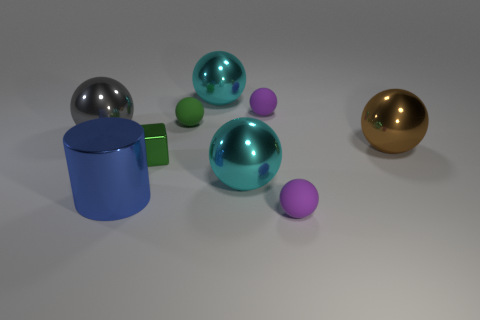What is the shape of the rubber thing that is the same color as the small metal object?
Keep it short and to the point. Sphere. There is a ball that is the same color as the tiny metal block; what size is it?
Provide a short and direct response. Small. What is the shape of the tiny object that is in front of the gray metallic object and behind the large cylinder?
Keep it short and to the point. Cube. The gray shiny thing that is the same shape as the tiny green matte thing is what size?
Make the answer very short. Large. Are there fewer big shiny cylinders that are in front of the shiny cube than tiny green metal blocks?
Your answer should be very brief. No. What is the size of the purple ball that is in front of the tiny green rubber ball?
Make the answer very short. Small. How many shiny things are the same color as the metal cube?
Your answer should be compact. 0. Are there any other things that are the same shape as the small green rubber object?
Provide a succinct answer. Yes. There is a small purple object behind the big sphere on the left side of the blue object; is there a purple ball that is left of it?
Provide a succinct answer. No. How many blue things have the same material as the brown object?
Make the answer very short. 1. 